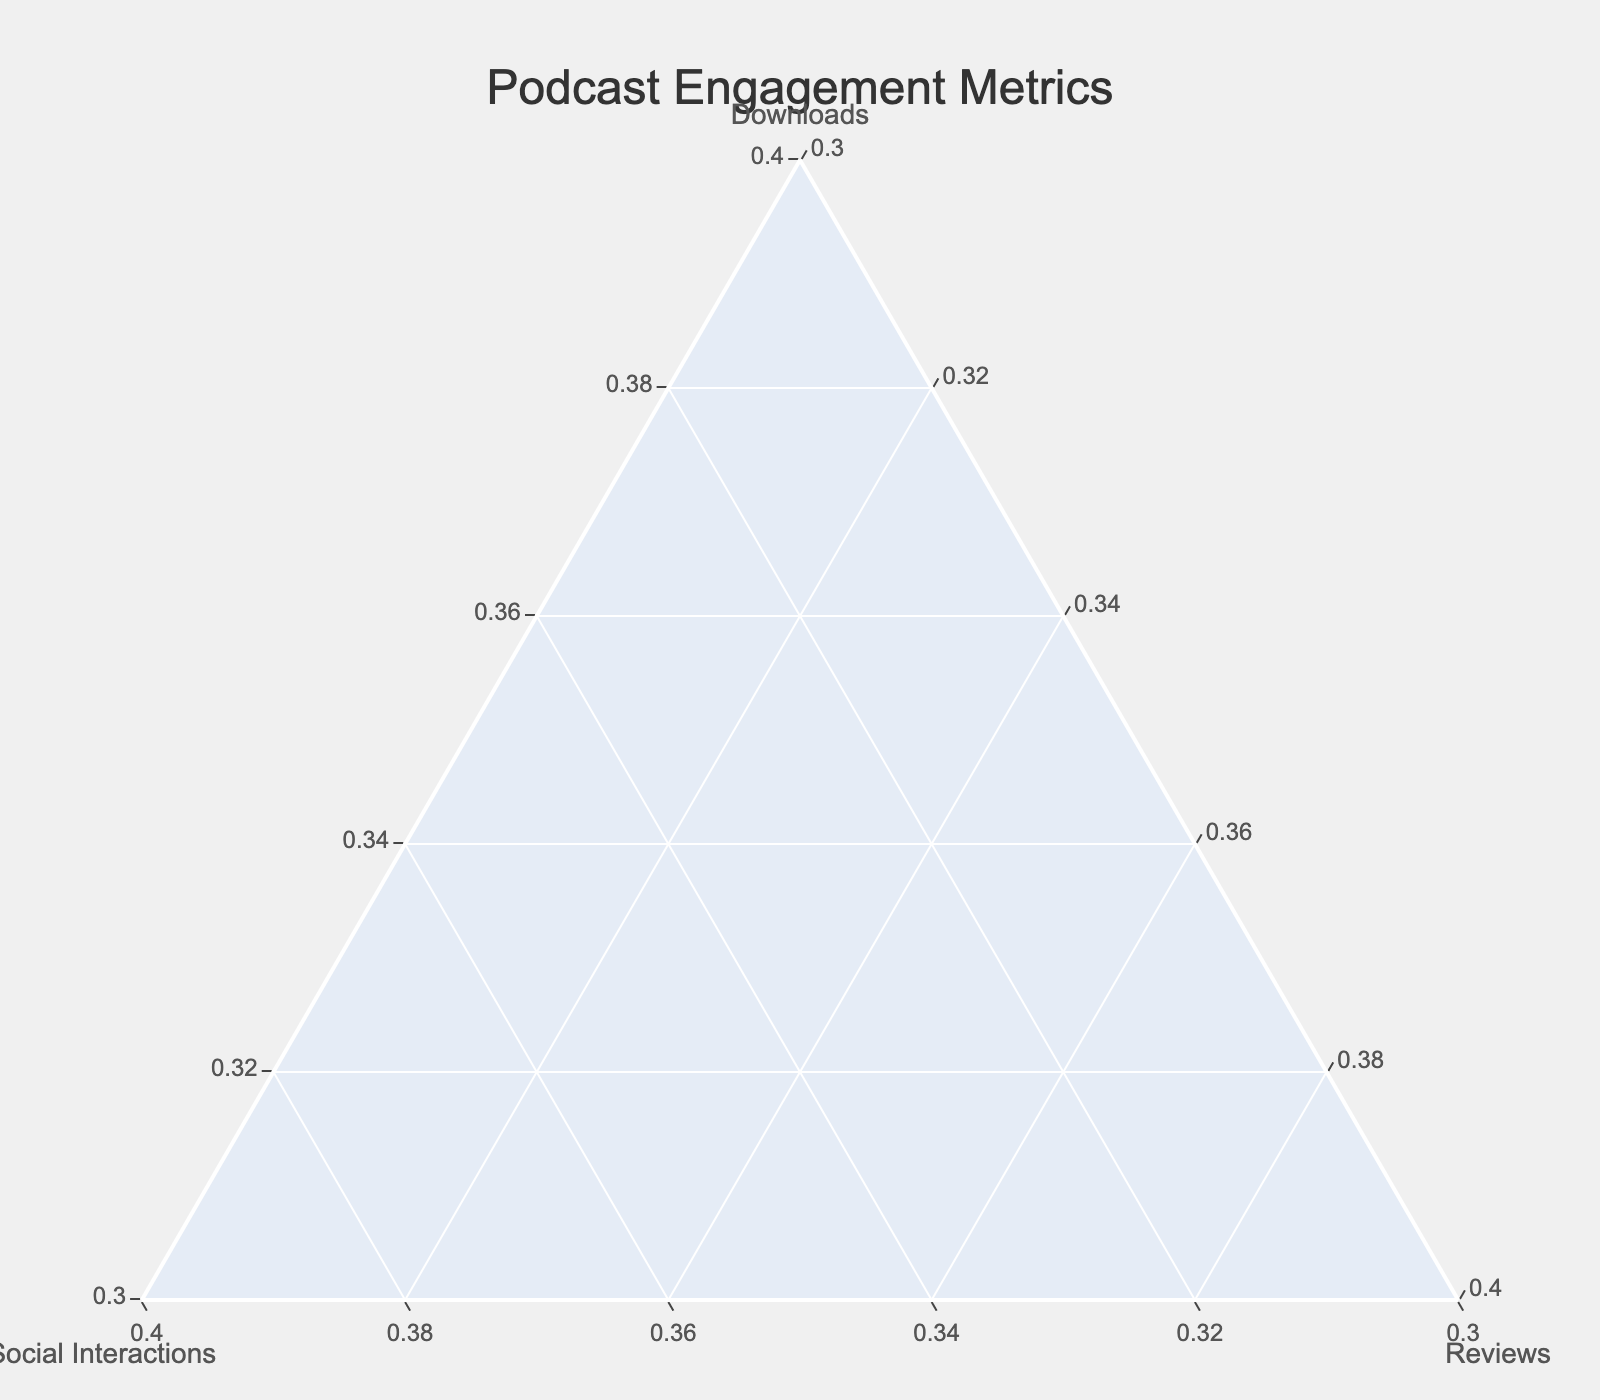What's the title of the figure? The title of the figure is usually displayed prominently at the top center of the plot. By looking at the figure, we can directly read the text in the title section.
Answer: Podcast Engagement Metrics Which axis represents the "Downloads" metric? The ternary plot typically displays three axes, each labeled with their respective metrics. By observing the labels on the axes, we can identify the "aaxis" as representing "Downloads".
Answer: The left axis How many podcasts have an equal proportion of "Reviews"? By looking at the markers' positions and checking the "Reviews" axis, we can see which markers are aligned horizontally at the same level. Eight podcasts are at the same "Reviews" level of 10%, and seven are at 15%.
Answer: Fifteen Which podcast has the highest proportion of "Downloads"? To find this, we observe the position of the markers on the "Downloads" axis. The marker farthest to the left indicates the highest proportion of downloads, which corresponds to "Bedtime Stories".
Answer: Bedtime Stories Compare "Tech Talk Today" and "Book Club Banter" in terms of social media interactions. Which one has a higher proportion? By locating the two podcasts on the ternary plot and comparing their positions relative to the "Social_Interactions" axis, we find that "Book Club Banter" has a higher proportion than "Tech Talk Today".
Answer: Book Club Banter What's the average proportion of "Downloads" for the podcasts "Movie Buff Musings" and "Parenting 101"? First, identify the positions of the markers for "Movie Buff Musings" and "Parenting 101" on the "Downloads" axis. Both have approximately 55% and 55%, respectively. Average them: (55+55)/2 = 55%.
Answer: 55% Which podcast has a balanced proportion of all three engagement metrics? A balanced proportion of all three metrics means the marker will be closer to the center of the ternary plot. By observing, "Parenting 101" appears to have a relatively balanced proportion.
Answer: Parenting 101 How many podcasts have "Downloads" as their highest engagement metric? By observing which markers are closest to the "Downloads" axis, we see that there are six such podcasts.
Answer: Six 